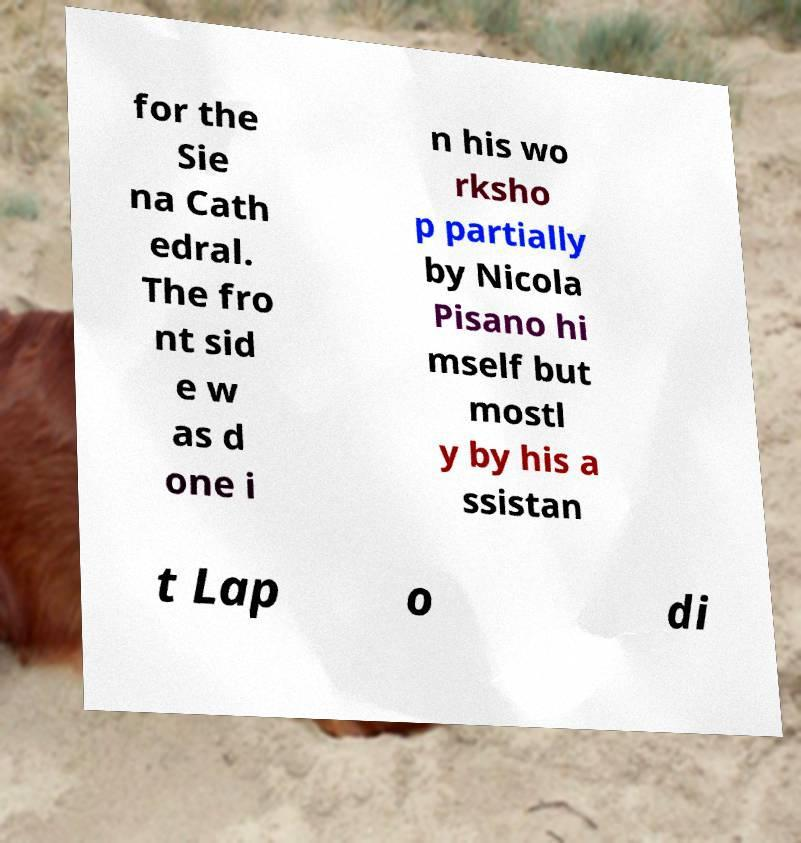What messages or text are displayed in this image? I need them in a readable, typed format. for the Sie na Cath edral. The fro nt sid e w as d one i n his wo rksho p partially by Nicola Pisano hi mself but mostl y by his a ssistan t Lap o di 